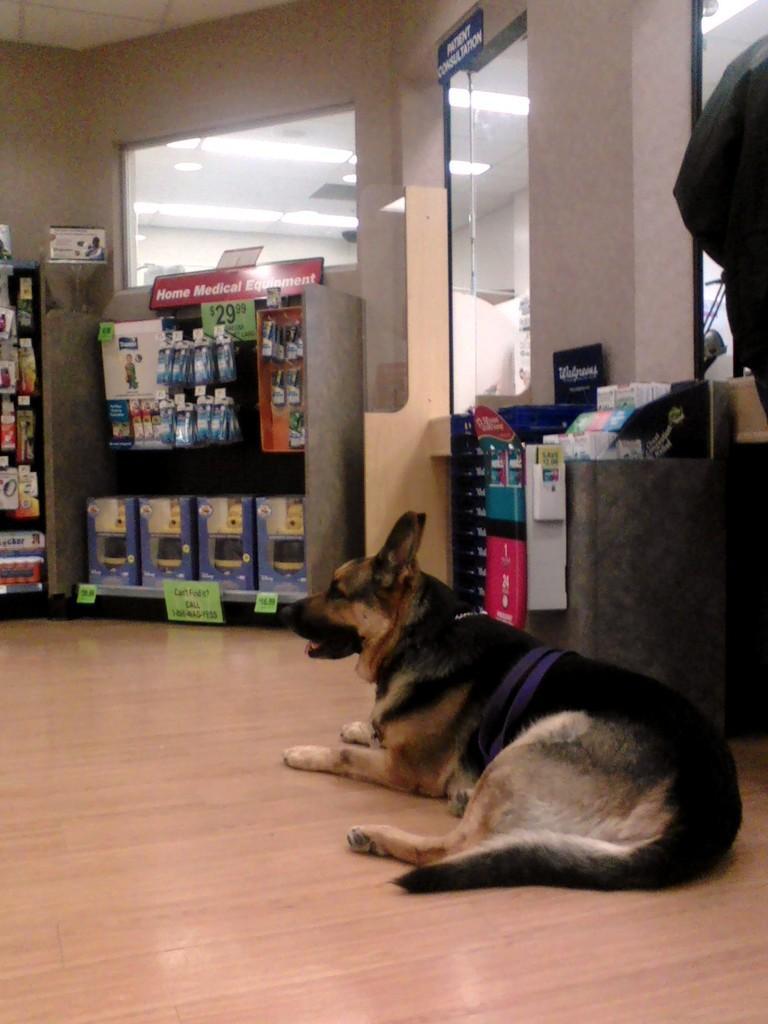Could you give a brief overview of what you see in this image? This picture is inside view of a room. In the center of the image we can see a dog is present. In the middle of the image we can see some objects, wall, glass, boards are there. At the top of the image roof is present. At the bottom of the image floor is there. 